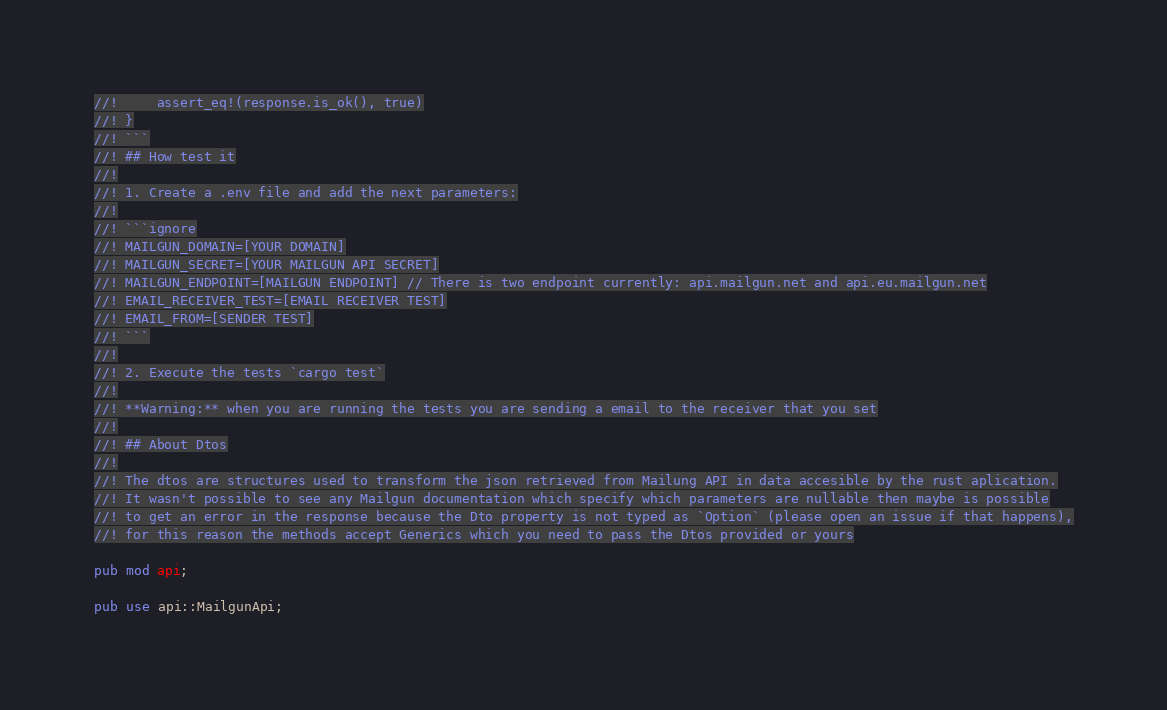<code> <loc_0><loc_0><loc_500><loc_500><_Rust_>//!     assert_eq!(response.is_ok(), true)
//! }
//! ```
//! ## How test it
//!
//! 1. Create a .env file and add the next parameters:
//!
//! ```ignore
//! MAILGUN_DOMAIN=[YOUR DOMAIN]
//! MAILGUN_SECRET=[YOUR MAILGUN API SECRET]
//! MAILGUN_ENDPOINT=[MAILGUN ENDPOINT] // There is two endpoint currently: api.mailgun.net and api.eu.mailgun.net
//! EMAIL_RECEIVER_TEST=[EMAIL RECEIVER TEST]
//! EMAIL_FROM=[SENDER TEST]
//! ```
//!
//! 2. Execute the tests `cargo test`
//!
//! **Warning:** when you are running the tests you are sending a email to the receiver that you set
//!
//! ## About Dtos
//!
//! The dtos are structures used to transform the json retrieved from Mailung API in data accesible by the rust aplication.
//! It wasn't possible to see any Mailgun documentation which specify which parameters are nullable then maybe is possible
//! to get an error in the response because the Dto property is not typed as `Option` (please open an issue if that happens),
//! for this reason the methods accept Generics which you need to pass the Dtos provided or yours

pub mod api;

pub use api::MailgunApi;
</code> 